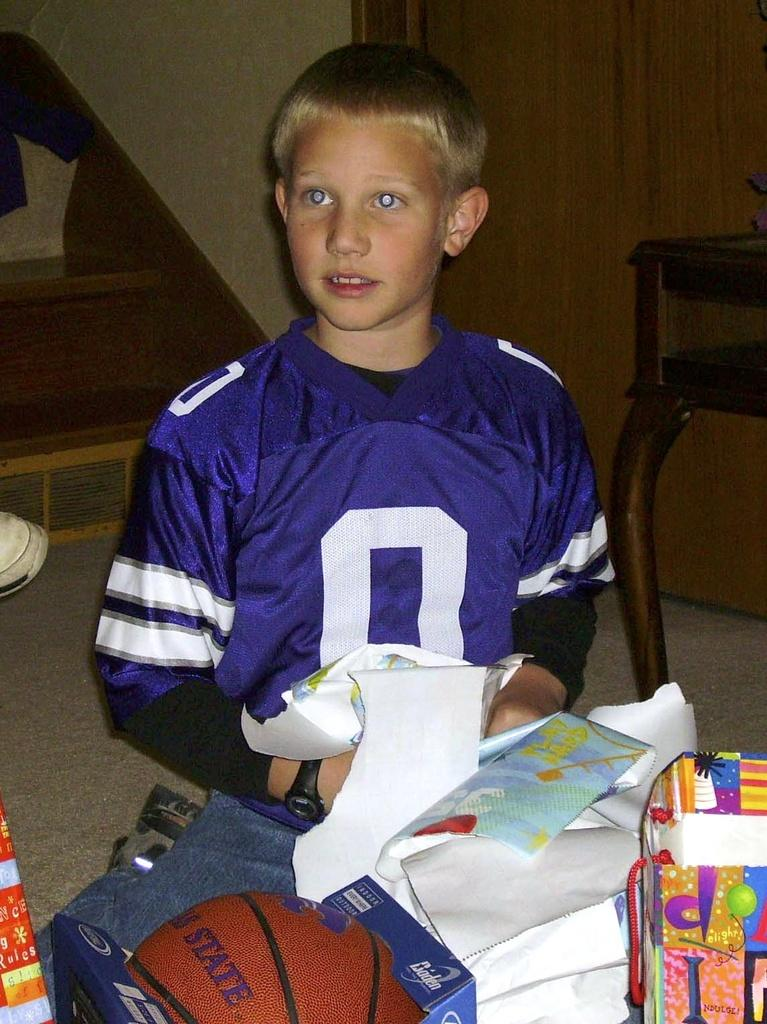Provide a one-sentence caption for the provided image. A young boy in a purple jersey with the number 0 on it opens gifts. 